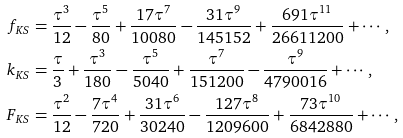Convert formula to latex. <formula><loc_0><loc_0><loc_500><loc_500>f _ { K S } & = \frac { \tau ^ { 3 } } { 1 2 } - \frac { \tau ^ { 5 } } { 8 0 } + \frac { 1 7 \tau ^ { 7 } } { 1 0 0 8 0 } - \frac { 3 1 \tau ^ { 9 } } { 1 4 5 1 5 2 } + \frac { 6 9 1 \tau ^ { 1 1 } } { 2 6 6 1 1 2 0 0 } + \cdots , \\ k _ { K S } & = \frac { \tau } { 3 } + \frac { \tau ^ { 3 } } { 1 8 0 } - \frac { \tau ^ { 5 } } { 5 0 4 0 } + \frac { \tau ^ { 7 } } { 1 5 1 2 0 0 } - \frac { \tau ^ { 9 } } { 4 7 9 0 0 1 6 } + \cdots , \\ F _ { K S } & = \frac { \tau ^ { 2 } } { 1 2 } - \frac { 7 \tau ^ { 4 } } { 7 2 0 } + \frac { 3 1 \tau ^ { 6 } } { 3 0 2 4 0 } - \frac { 1 2 7 \tau ^ { 8 } } { 1 2 0 9 6 0 0 } + \frac { 7 3 \tau ^ { 1 0 } } { 6 8 4 2 8 8 0 } + \cdots ,</formula> 